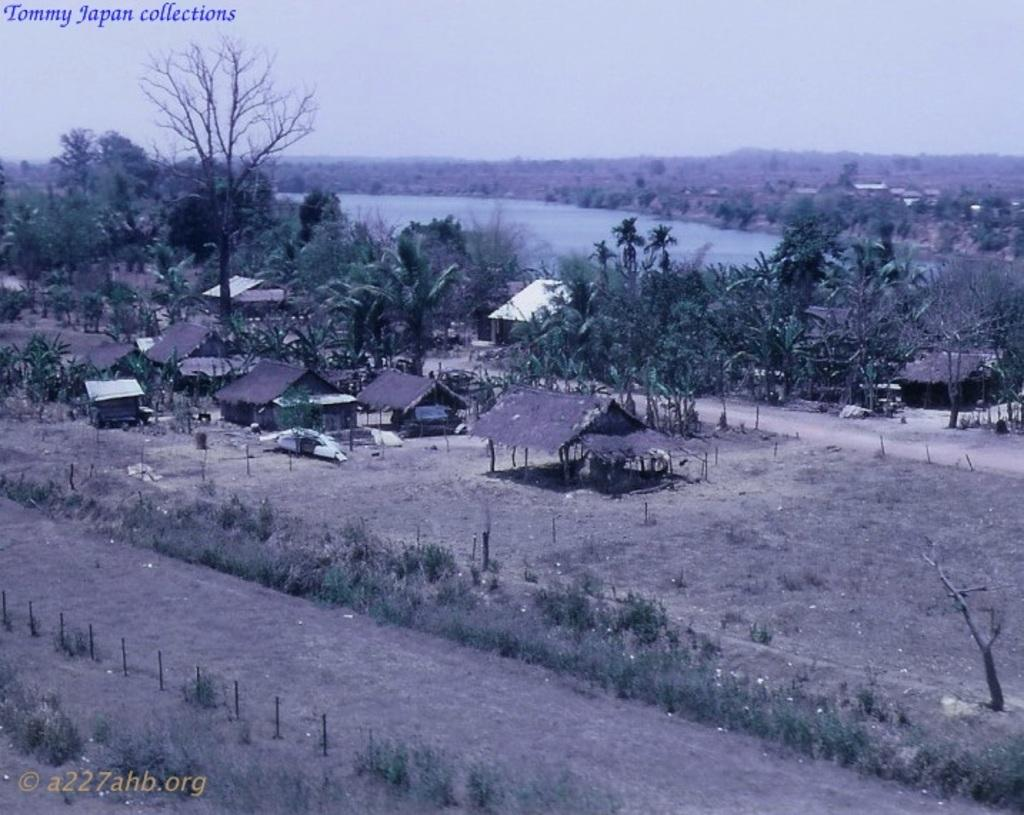What type of vegetation can be seen in the image? There are plants and trees in the image. What type of structures are present in the image? There are houses in the image. What natural element is visible in the image? There is water visible in the image. What is present in the top left and bottom left corners of the image? There is text in the top left and bottom left corners of the image. Can you tell me how many berries are on the trees in the image? There are no berries mentioned or visible in the image; it only features plants, houses, trees, water, and text. What type of spot is present on the houses in the image? There is no mention of any spots on the houses in the image; they are simply described as structures. 